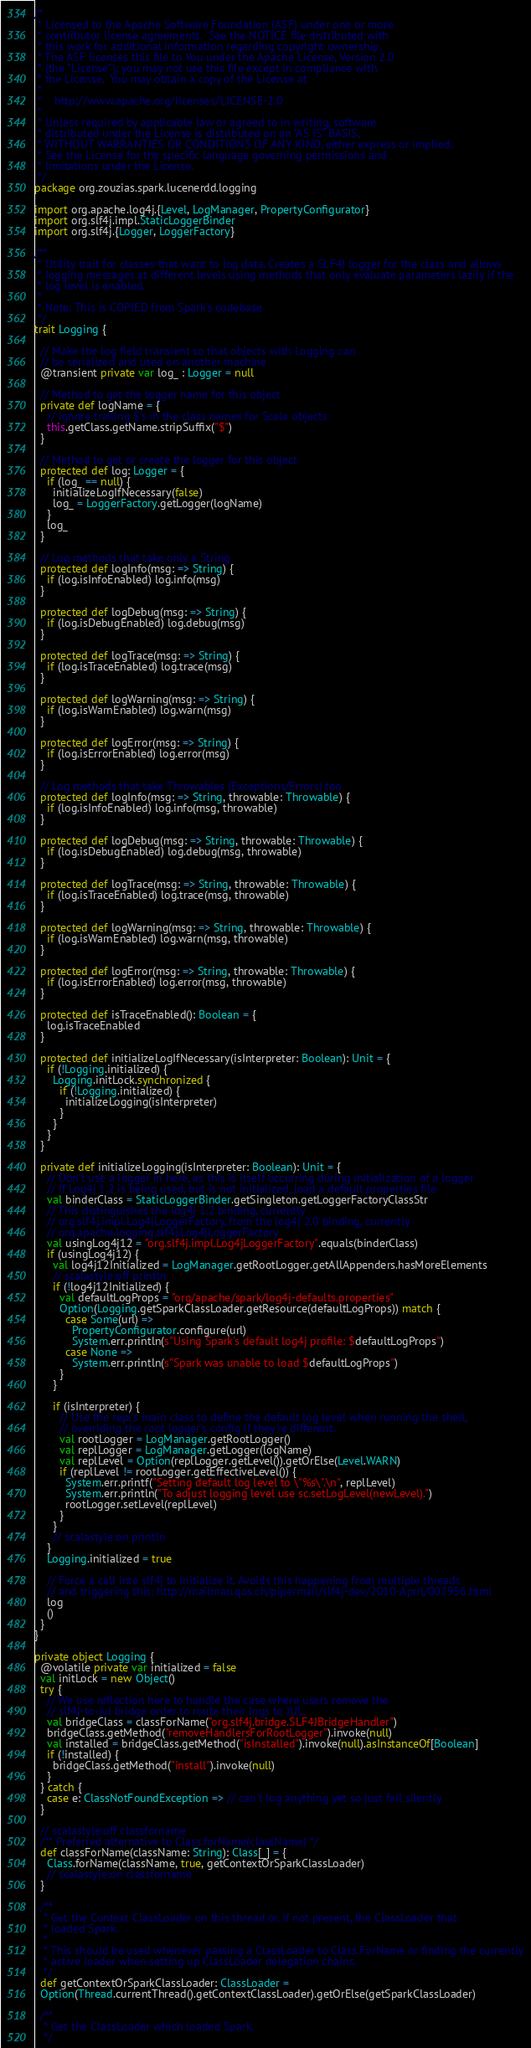Convert code to text. <code><loc_0><loc_0><loc_500><loc_500><_Scala_>/*
 * Licensed to the Apache Software Foundation (ASF) under one or more
 * contributor license agreements.  See the NOTICE file distributed with
 * this work for additional information regarding copyright ownership.
 * The ASF licenses this file to You under the Apache License, Version 2.0
 * (the "License"); you may not use this file except in compliance with
 * the License.  You may obtain a copy of the License at
 *
 *    http://www.apache.org/licenses/LICENSE-2.0
 *
 * Unless required by applicable law or agreed to in writing, software
 * distributed under the License is distributed on an "AS IS" BASIS,
 * WITHOUT WARRANTIES OR CONDITIONS OF ANY KIND, either express or implied.
 * See the License for the specific language governing permissions and
 * limitations under the License.
 */
package org.zouzias.spark.lucenerdd.logging

import org.apache.log4j.{Level, LogManager, PropertyConfigurator}
import org.slf4j.impl.StaticLoggerBinder
import org.slf4j.{Logger, LoggerFactory}

/**
 * Utility trait for classes that want to log data. Creates a SLF4J logger for the class and allows
 * logging messages at different levels using methods that only evaluate parameters lazily if the
 * log level is enabled.
 *
 * Note: This is COPIED from Spark's codebase
 */
trait Logging {

  // Make the log field transient so that objects with Logging can
  // be serialized and used on another machine
  @transient private var log_ : Logger = null

  // Method to get the logger name for this object
  private def logName = {
    // Ignore trailing $'s in the class names for Scala objects
    this.getClass.getName.stripSuffix("$")
  }

  // Method to get or create the logger for this object
  protected def log: Logger = {
    if (log_ == null) {
      initializeLogIfNecessary(false)
      log_ = LoggerFactory.getLogger(logName)
    }
    log_
  }

  // Log methods that take only a String
  protected def logInfo(msg: => String) {
    if (log.isInfoEnabled) log.info(msg)
  }

  protected def logDebug(msg: => String) {
    if (log.isDebugEnabled) log.debug(msg)
  }

  protected def logTrace(msg: => String) {
    if (log.isTraceEnabled) log.trace(msg)
  }

  protected def logWarning(msg: => String) {
    if (log.isWarnEnabled) log.warn(msg)
  }

  protected def logError(msg: => String) {
    if (log.isErrorEnabled) log.error(msg)
  }

  // Log methods that take Throwables (Exceptions/Errors) too
  protected def logInfo(msg: => String, throwable: Throwable) {
    if (log.isInfoEnabled) log.info(msg, throwable)
  }

  protected def logDebug(msg: => String, throwable: Throwable) {
    if (log.isDebugEnabled) log.debug(msg, throwable)
  }

  protected def logTrace(msg: => String, throwable: Throwable) {
    if (log.isTraceEnabled) log.trace(msg, throwable)
  }

  protected def logWarning(msg: => String, throwable: Throwable) {
    if (log.isWarnEnabled) log.warn(msg, throwable)
  }

  protected def logError(msg: => String, throwable: Throwable) {
    if (log.isErrorEnabled) log.error(msg, throwable)
  }

  protected def isTraceEnabled(): Boolean = {
    log.isTraceEnabled
  }

  protected def initializeLogIfNecessary(isInterpreter: Boolean): Unit = {
    if (!Logging.initialized) {
      Logging.initLock.synchronized {
        if (!Logging.initialized) {
          initializeLogging(isInterpreter)
        }
      }
    }
  }

  private def initializeLogging(isInterpreter: Boolean): Unit = {
    // Don't use a logger in here, as this is itself occurring during initialization of a logger
    // If Log4j 1.2 is being used, but is not initialized, load a default properties file
    val binderClass = StaticLoggerBinder.getSingleton.getLoggerFactoryClassStr
    // This distinguishes the log4j 1.2 binding, currently
    // org.slf4j.impl.Log4jLoggerFactory, from the log4j 2.0 binding, currently
    // org.apache.logging.slf4j.Log4jLoggerFactory
    val usingLog4j12 = "org.slf4j.impl.Log4jLoggerFactory".equals(binderClass)
    if (usingLog4j12) {
      val log4j12Initialized = LogManager.getRootLogger.getAllAppenders.hasMoreElements
      // scalastyle:off println
      if (!log4j12Initialized) {
        val defaultLogProps = "org/apache/spark/log4j-defaults.properties"
        Option(Logging.getSparkClassLoader.getResource(defaultLogProps)) match {
          case Some(url) =>
            PropertyConfigurator.configure(url)
            System.err.println(s"Using Spark's default log4j profile: $defaultLogProps")
          case None =>
            System.err.println(s"Spark was unable to load $defaultLogProps")
        }
      }

      if (isInterpreter) {
        // Use the repl's main class to define the default log level when running the shell,
        // overriding the root logger's config if they're different.
        val rootLogger = LogManager.getRootLogger()
        val replLogger = LogManager.getLogger(logName)
        val replLevel = Option(replLogger.getLevel()).getOrElse(Level.WARN)
        if (replLevel != rootLogger.getEffectiveLevel()) {
          System.err.printf("Setting default log level to \"%s\".\n", replLevel)
          System.err.println("To adjust logging level use sc.setLogLevel(newLevel).")
          rootLogger.setLevel(replLevel)
        }
      }
      // scalastyle:on println
    }
    Logging.initialized = true

    // Force a call into slf4j to initialize it. Avoids this happening from multiple threads
    // and triggering this: http://mailman.qos.ch/pipermail/slf4j-dev/2010-April/002956.html
    log
    ()
  }
}

private object Logging {
  @volatile private var initialized = false
  val initLock = new Object()
  try {
    // We use reflection here to handle the case where users remove the
    // slf4j-to-jul bridge order to route their logs to JUL.
    val bridgeClass = classForName("org.slf4j.bridge.SLF4JBridgeHandler")
    bridgeClass.getMethod("removeHandlersForRootLogger").invoke(null)
    val installed = bridgeClass.getMethod("isInstalled").invoke(null).asInstanceOf[Boolean]
    if (!installed) {
      bridgeClass.getMethod("install").invoke(null)
    }
  } catch {
    case e: ClassNotFoundException => // can't log anything yet so just fail silently
  }

  // scalastyle:off classforname
  /** Preferred alternative to Class.forName(className) */
  def classForName(className: String): Class[_] = {
    Class.forName(className, true, getContextOrSparkClassLoader)
    // scalastyle:on classforname
  }

  /**
   * Get the Context ClassLoader on this thread or, if not present, the ClassLoader that
   * loaded Spark.
   *
   * This should be used whenever passing a ClassLoader to Class.ForName or finding the currently
   * active loader when setting up ClassLoader delegation chains.
   */
  def getContextOrSparkClassLoader: ClassLoader =
  Option(Thread.currentThread().getContextClassLoader).getOrElse(getSparkClassLoader)

  /**
   * Get the ClassLoader which loaded Spark.
   */</code> 